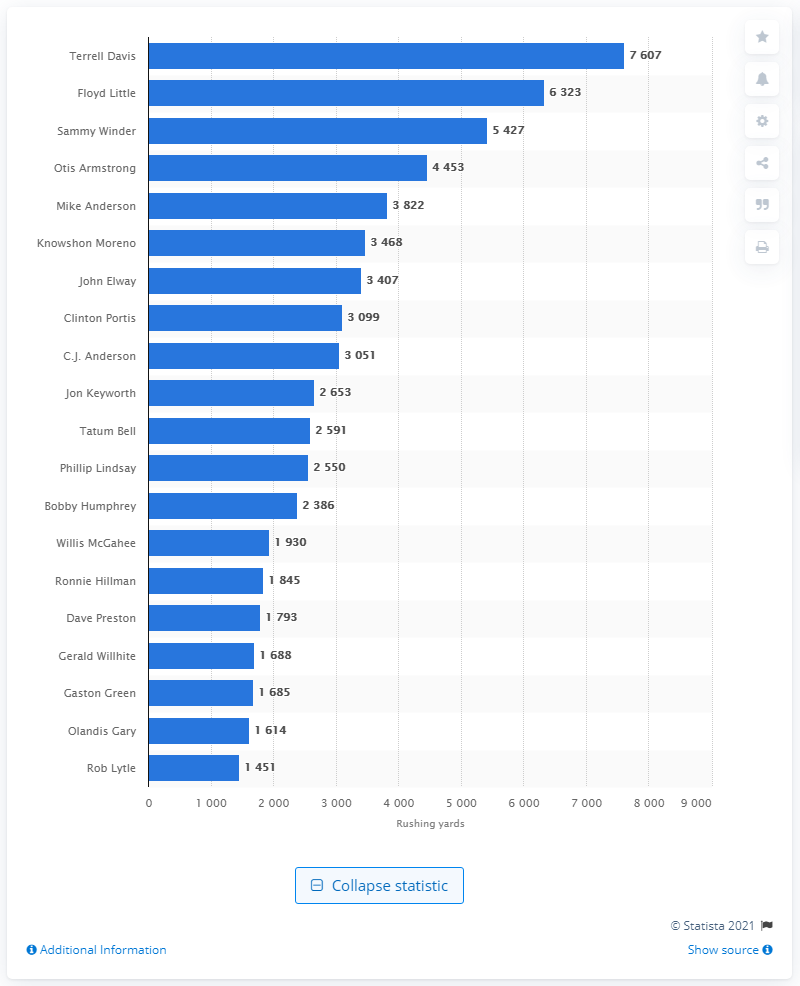List a handful of essential elements in this visual. Terrell Davis is the career rushing leader of the Denver Broncos. 